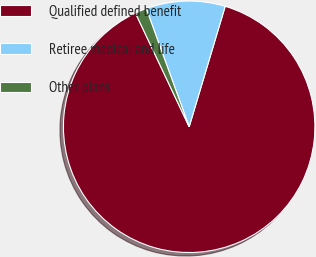<chart> <loc_0><loc_0><loc_500><loc_500><pie_chart><fcel>Qualified defined benefit<fcel>Retiree medical and life<fcel>Other plans<nl><fcel>88.36%<fcel>10.17%<fcel>1.48%<nl></chart> 